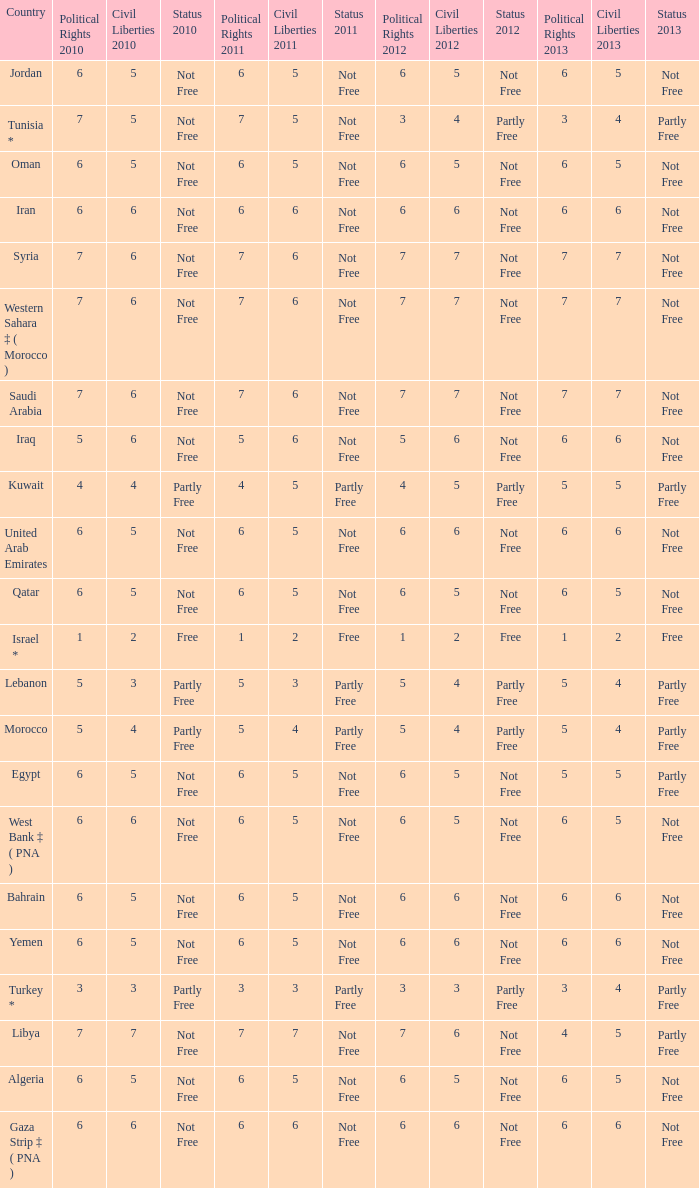What is the total number of civil liberties 2011 values having 2010 political rights values under 3 and 2011 political rights values under 1? 0.0. 